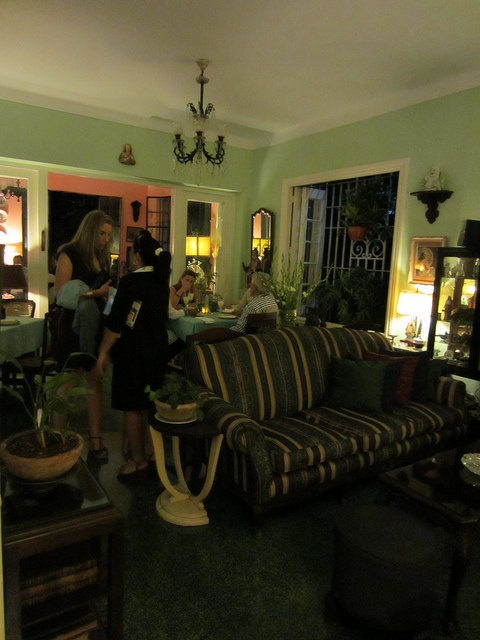Describe the objects in this image and their specific colors. I can see couch in olive and black tones, people in olive, black, and maroon tones, potted plant in olive, black, maroon, and darkgreen tones, people in olive, black, darkgreen, and maroon tones, and potted plant in black, darkgreen, and olive tones in this image. 